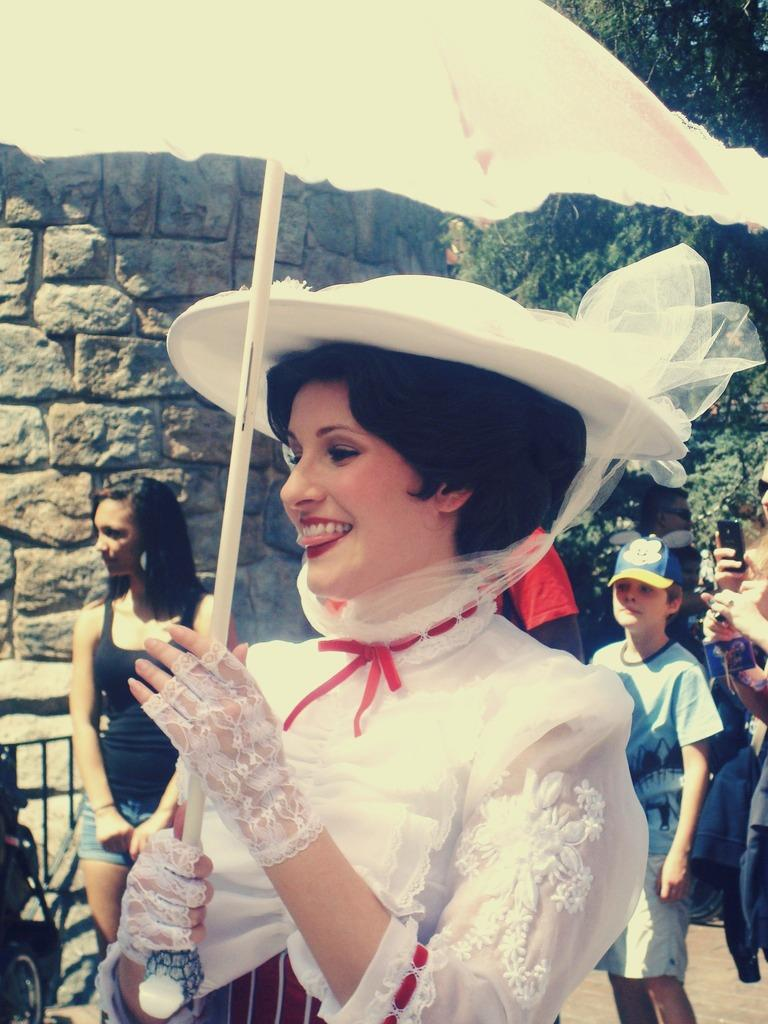What is the main subject of the image? There is a woman standing in the middle of the image. What is the woman doing in the image? The woman is smiling in the image. What object is the woman holding? The woman is holding an umbrella. Can you describe the people behind the woman? There are people standing behind the woman. What can be seen in the background of the image? There is a wall and a tree visible in the background. What type of trick is the woman performing with the tramp in the image? There is no tramp or trick present in the image; it features a woman holding an umbrella. How many curves can be seen in the image? There are no curves mentioned or visible in the image. 